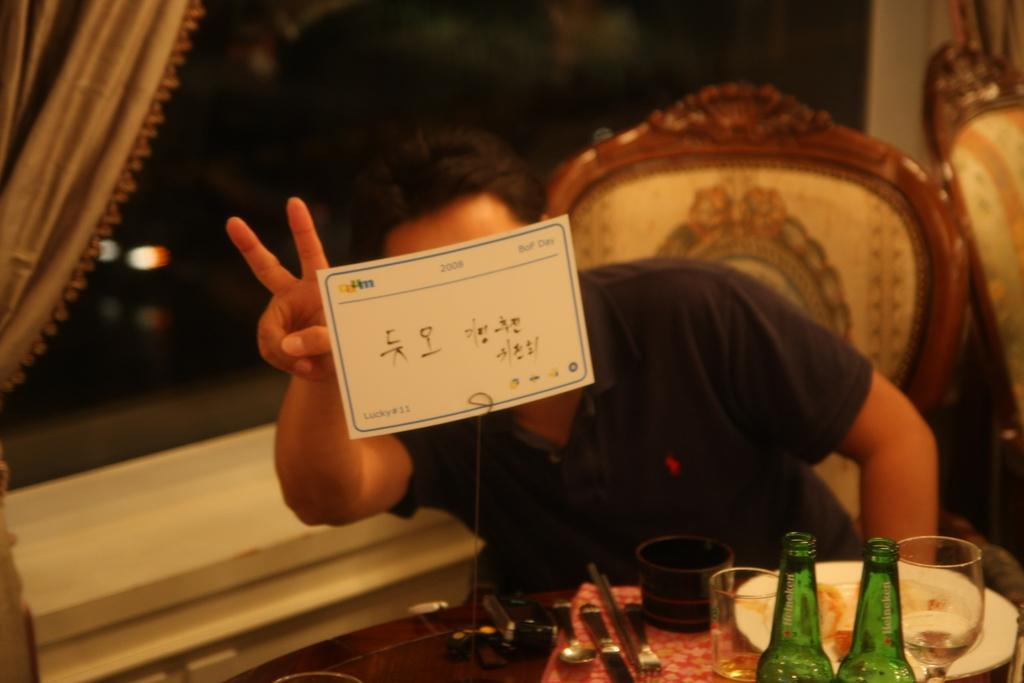Could you give a brief overview of what you see in this image? In this image i can see a man is sitting on a chair in front of a table. On the table we have couple of objects. 